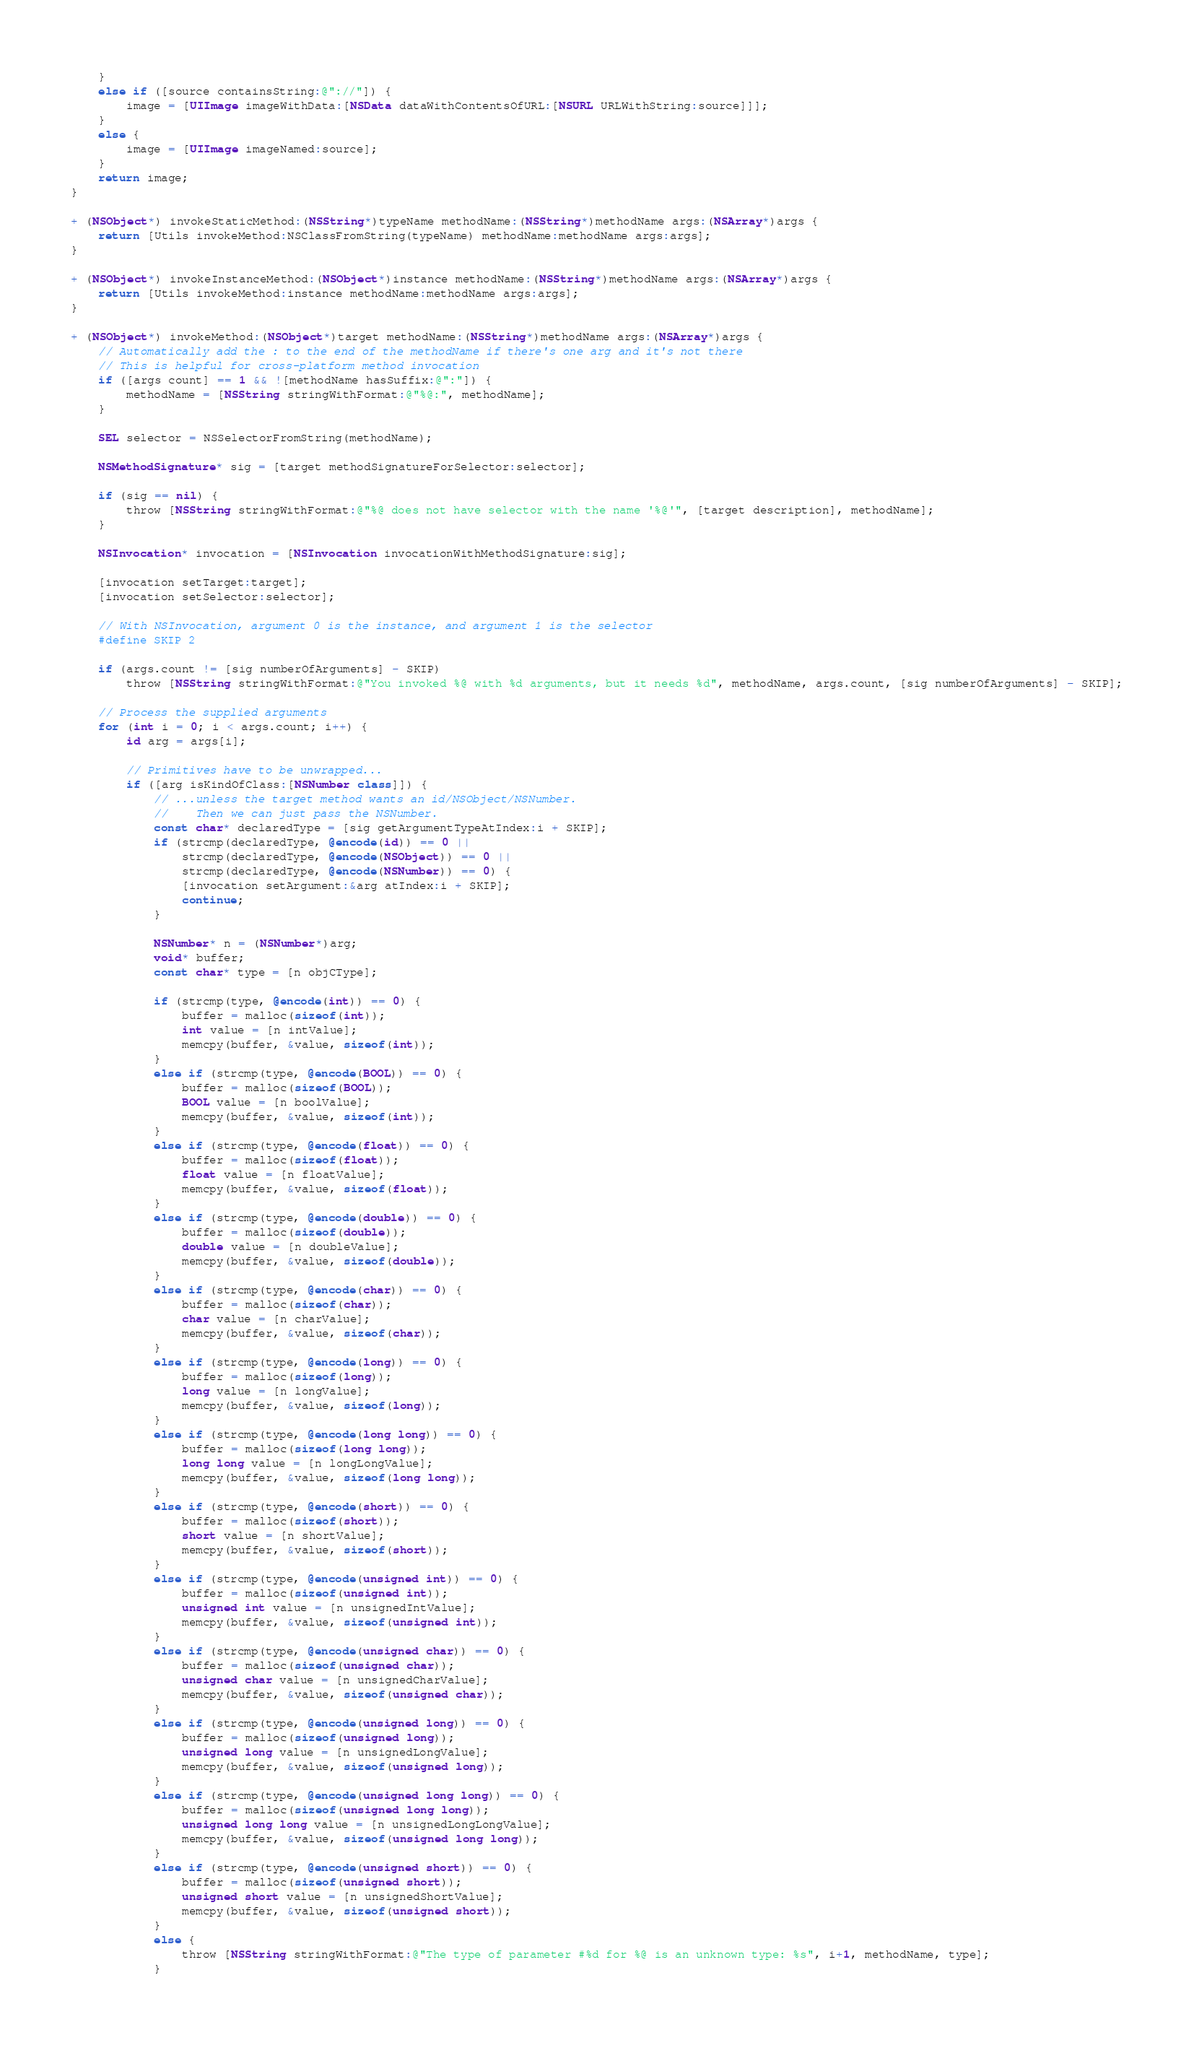<code> <loc_0><loc_0><loc_500><loc_500><_ObjectiveC_>    }
    else if ([source containsString:@"://"]) {
        image = [UIImage imageWithData:[NSData dataWithContentsOfURL:[NSURL URLWithString:source]]];
    }
    else {
        image = [UIImage imageNamed:source];
    }
    return image;
}

+ (NSObject*) invokeStaticMethod:(NSString*)typeName methodName:(NSString*)methodName args:(NSArray*)args {
    return [Utils invokeMethod:NSClassFromString(typeName) methodName:methodName args:args];
}

+ (NSObject*) invokeInstanceMethod:(NSObject*)instance methodName:(NSString*)methodName args:(NSArray*)args {
    return [Utils invokeMethod:instance methodName:methodName args:args];
}

+ (NSObject*) invokeMethod:(NSObject*)target methodName:(NSString*)methodName args:(NSArray*)args {
    // Automatically add the : to the end of the methodName if there's one arg and it's not there
    // This is helpful for cross-platform method invocation
    if ([args count] == 1 && ![methodName hasSuffix:@":"]) {
        methodName = [NSString stringWithFormat:@"%@:", methodName];
    }

    SEL selector = NSSelectorFromString(methodName);

    NSMethodSignature* sig = [target methodSignatureForSelector:selector];

    if (sig == nil) {
        throw [NSString stringWithFormat:@"%@ does not have selector with the name '%@'", [target description], methodName];
    }

    NSInvocation* invocation = [NSInvocation invocationWithMethodSignature:sig];

    [invocation setTarget:target];
    [invocation setSelector:selector];

    // With NSInvocation, argument 0 is the instance, and argument 1 is the selector
    #define SKIP 2

    if (args.count != [sig numberOfArguments] - SKIP)
        throw [NSString stringWithFormat:@"You invoked %@ with %d arguments, but it needs %d", methodName, args.count, [sig numberOfArguments] - SKIP];

    // Process the supplied arguments
    for (int i = 0; i < args.count; i++) {
        id arg = args[i];

        // Primitives have to be unwrapped...
        if ([arg isKindOfClass:[NSNumber class]]) {
            // ...unless the target method wants an id/NSObject/NSNumber.
            //    Then we can just pass the NSNumber.
            const char* declaredType = [sig getArgumentTypeAtIndex:i + SKIP];
            if (strcmp(declaredType, @encode(id)) == 0 ||
                strcmp(declaredType, @encode(NSObject)) == 0 ||
                strcmp(declaredType, @encode(NSNumber)) == 0) {
                [invocation setArgument:&arg atIndex:i + SKIP];
                continue;
            }

            NSNumber* n = (NSNumber*)arg;
            void* buffer;
            const char* type = [n objCType];

            if (strcmp(type, @encode(int)) == 0) {
                buffer = malloc(sizeof(int));
                int value = [n intValue];
                memcpy(buffer, &value, sizeof(int));
            }
            else if (strcmp(type, @encode(BOOL)) == 0) {
                buffer = malloc(sizeof(BOOL));
                BOOL value = [n boolValue];
                memcpy(buffer, &value, sizeof(int));
            }
            else if (strcmp(type, @encode(float)) == 0) {
                buffer = malloc(sizeof(float));
                float value = [n floatValue];
                memcpy(buffer, &value, sizeof(float));
            }
            else if (strcmp(type, @encode(double)) == 0) {
                buffer = malloc(sizeof(double));
                double value = [n doubleValue];
                memcpy(buffer, &value, sizeof(double));
            }
            else if (strcmp(type, @encode(char)) == 0) {
                buffer = malloc(sizeof(char));
                char value = [n charValue];
                memcpy(buffer, &value, sizeof(char));
            }
            else if (strcmp(type, @encode(long)) == 0) {
                buffer = malloc(sizeof(long));
                long value = [n longValue];
                memcpy(buffer, &value, sizeof(long));
            }
            else if (strcmp(type, @encode(long long)) == 0) {
                buffer = malloc(sizeof(long long));
                long long value = [n longLongValue];
                memcpy(buffer, &value, sizeof(long long));
            }
            else if (strcmp(type, @encode(short)) == 0) {
                buffer = malloc(sizeof(short));
                short value = [n shortValue];
                memcpy(buffer, &value, sizeof(short));
            }
            else if (strcmp(type, @encode(unsigned int)) == 0) {
                buffer = malloc(sizeof(unsigned int));
                unsigned int value = [n unsignedIntValue];
                memcpy(buffer, &value, sizeof(unsigned int));
            }
            else if (strcmp(type, @encode(unsigned char)) == 0) {
                buffer = malloc(sizeof(unsigned char));
                unsigned char value = [n unsignedCharValue];
                memcpy(buffer, &value, sizeof(unsigned char));
            }
            else if (strcmp(type, @encode(unsigned long)) == 0) {
                buffer = malloc(sizeof(unsigned long));
                unsigned long value = [n unsignedLongValue];
                memcpy(buffer, &value, sizeof(unsigned long));
            }
            else if (strcmp(type, @encode(unsigned long long)) == 0) {
                buffer = malloc(sizeof(unsigned long long));
                unsigned long long value = [n unsignedLongLongValue];
                memcpy(buffer, &value, sizeof(unsigned long long));
            }
            else if (strcmp(type, @encode(unsigned short)) == 0) {
                buffer = malloc(sizeof(unsigned short));
                unsigned short value = [n unsignedShortValue];
                memcpy(buffer, &value, sizeof(unsigned short));
            }
            else {
                throw [NSString stringWithFormat:@"The type of parameter #%d for %@ is an unknown type: %s", i+1, methodName, type];
            }
</code> 